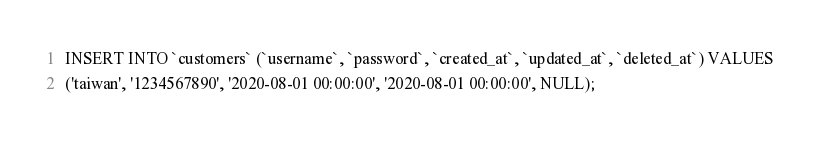Convert code to text. <code><loc_0><loc_0><loc_500><loc_500><_SQL_>INSERT INTO `customers` (`username`, `password`, `created_at`, `updated_at`, `deleted_at`) VALUES
('taiwan', '1234567890', '2020-08-01 00:00:00', '2020-08-01 00:00:00', NULL);</code> 